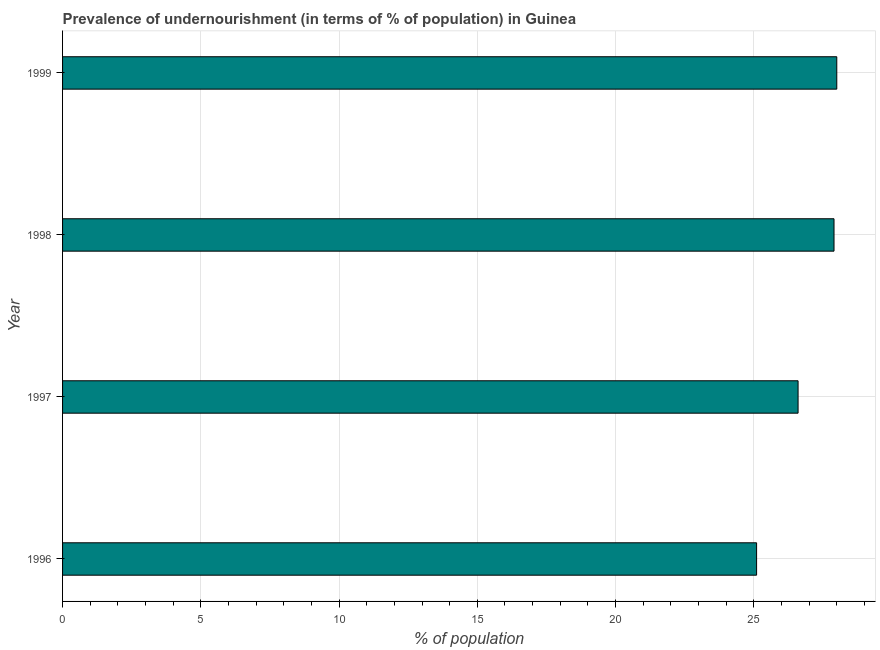What is the title of the graph?
Offer a terse response. Prevalence of undernourishment (in terms of % of population) in Guinea. What is the label or title of the X-axis?
Ensure brevity in your answer.  % of population. What is the percentage of undernourished population in 1998?
Your answer should be compact. 27.9. Across all years, what is the maximum percentage of undernourished population?
Give a very brief answer. 28. Across all years, what is the minimum percentage of undernourished population?
Offer a terse response. 25.1. What is the sum of the percentage of undernourished population?
Offer a very short reply. 107.6. What is the difference between the percentage of undernourished population in 1998 and 1999?
Provide a succinct answer. -0.1. What is the average percentage of undernourished population per year?
Provide a short and direct response. 26.9. What is the median percentage of undernourished population?
Your response must be concise. 27.25. In how many years, is the percentage of undernourished population greater than 28 %?
Make the answer very short. 0. What is the difference between the highest and the second highest percentage of undernourished population?
Your answer should be compact. 0.1. Is the sum of the percentage of undernourished population in 1996 and 1999 greater than the maximum percentage of undernourished population across all years?
Your answer should be compact. Yes. In how many years, is the percentage of undernourished population greater than the average percentage of undernourished population taken over all years?
Keep it short and to the point. 2. Are the values on the major ticks of X-axis written in scientific E-notation?
Your answer should be compact. No. What is the % of population of 1996?
Give a very brief answer. 25.1. What is the % of population of 1997?
Ensure brevity in your answer.  26.6. What is the % of population of 1998?
Ensure brevity in your answer.  27.9. What is the difference between the % of population in 1996 and 1998?
Give a very brief answer. -2.8. What is the difference between the % of population in 1996 and 1999?
Your answer should be compact. -2.9. What is the difference between the % of population in 1998 and 1999?
Give a very brief answer. -0.1. What is the ratio of the % of population in 1996 to that in 1997?
Keep it short and to the point. 0.94. What is the ratio of the % of population in 1996 to that in 1998?
Offer a very short reply. 0.9. What is the ratio of the % of population in 1996 to that in 1999?
Ensure brevity in your answer.  0.9. What is the ratio of the % of population in 1997 to that in 1998?
Give a very brief answer. 0.95. What is the ratio of the % of population in 1997 to that in 1999?
Give a very brief answer. 0.95. What is the ratio of the % of population in 1998 to that in 1999?
Your answer should be very brief. 1. 